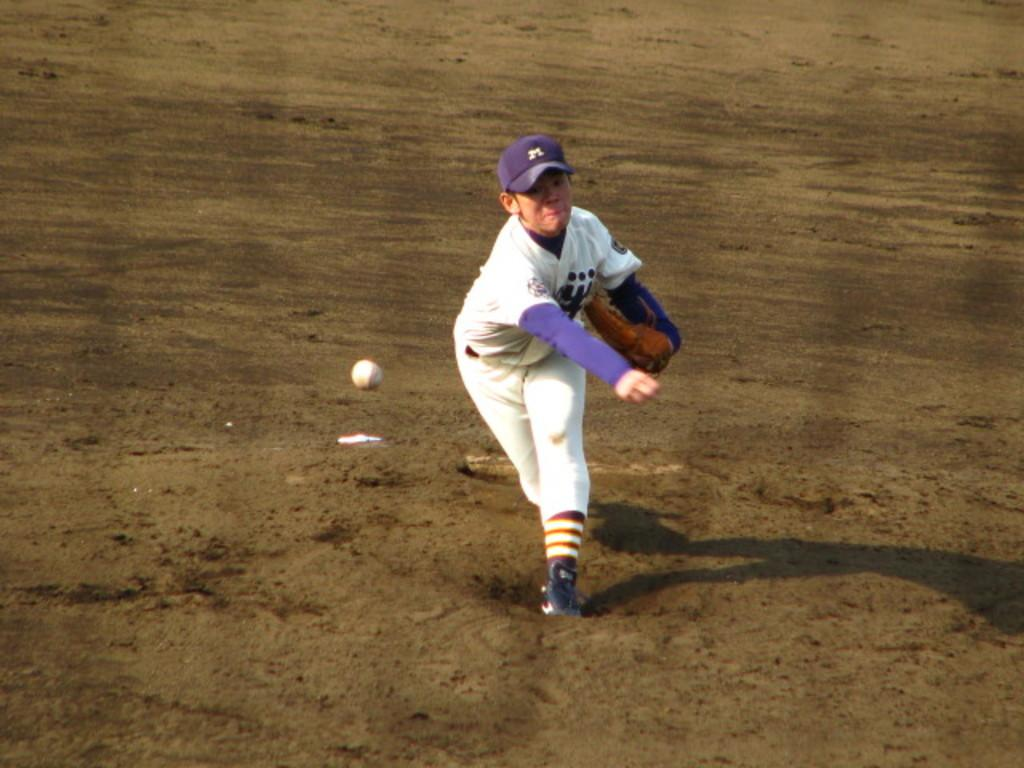What object can be seen in the image? There is a ball in the image. Who is present in the image? There is a boy in the image. What is the boy wearing on his head? The boy is wearing a blue cap. What is the boy wearing on his body? The boy is wearing a white dress. What type of train can be seen in the image? There is no train present in the image. Can you hear the frog croaking in the image? There is no frog present in the image, so it cannot be heard croaking. 